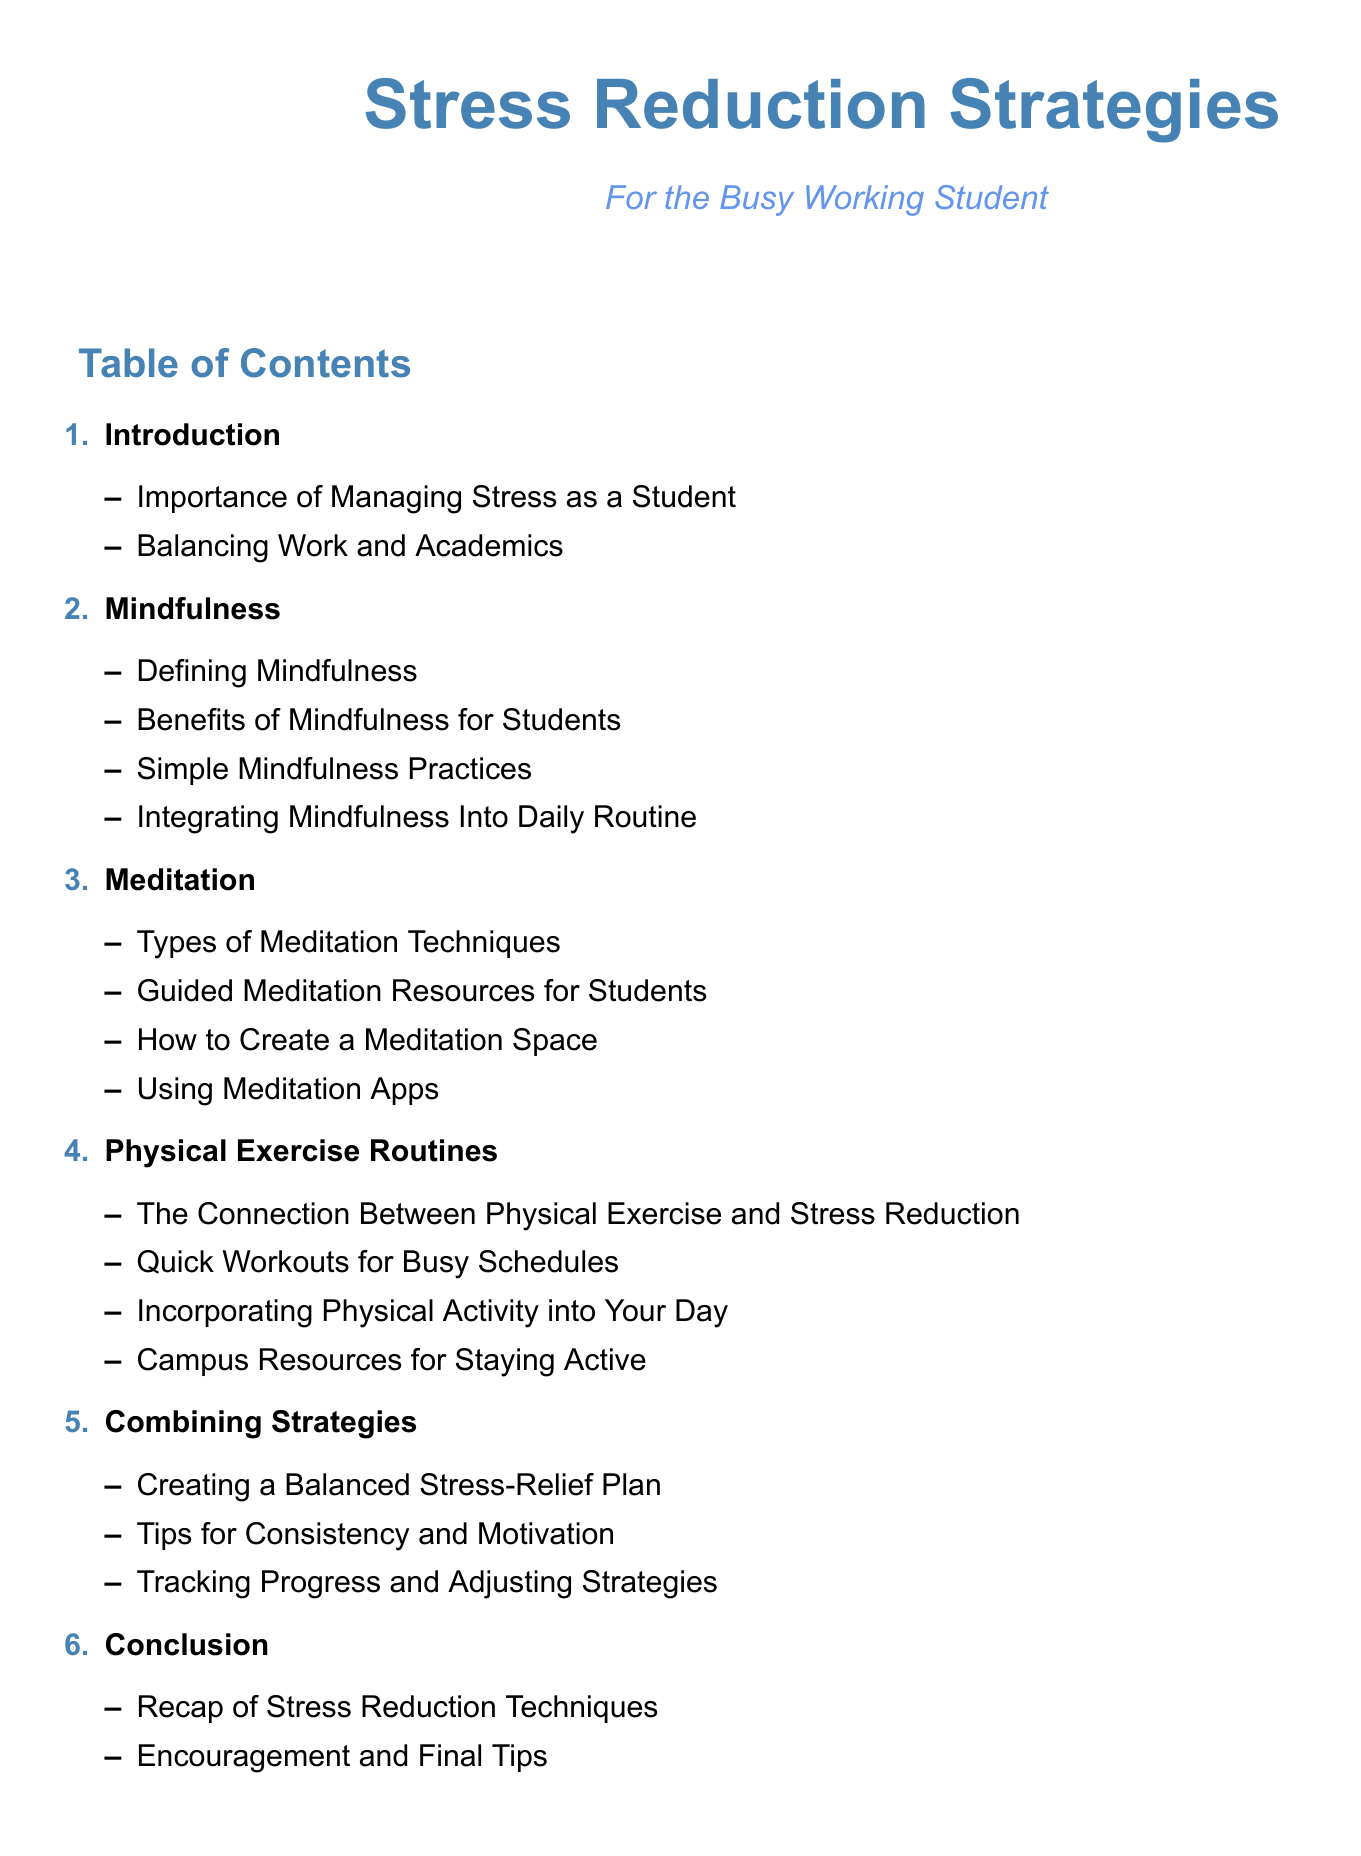What is the document about? The document provides strategies for stress reduction specifically oriented for busy working students.
Answer: Stress Reduction Strategies How many main sections are included in the table of contents? The sections listed under the table of contents are numbered 1 through 6, indicating there are six main sections.
Answer: 6 What is one benefit of mindfulness mentioned? The document discusses mindfulness and its benefits, which are specific to students balancing work and academics.
Answer: Benefits of Mindfulness for Students What is a simple mindfulness practice suggested? The table of contents lists "Simple Mindfulness Practices" as a subsection under mindfulness, indicating practices that can be easily incorporated.
Answer: Simple Mindfulness Practices Which type of meditation resources does the document provide? The document includes suggestions for guided meditation resources that are accessible for students.
Answer: Guided Meditation Resources for Students What should students create to enhance their meditation experience? The document suggests creating a designated space for meditation to enhance the practice.
Answer: Create a Meditation Space How can students incorporate physical activity according to the document? The section on physical exercise outlines ways to integrate physical activity into a busy student's daily routine.
Answer: Incorporating Physical Activity into Your Day What strategy is recommended for maintaining stress relief consistency? There are tips provided specifically aimed at ensuring students remain consistent and motivated in their stress relief practices.
Answer: Tips for Consistency and Motivation What does the conclusion recap? The conclusion summarizes the various stress reduction techniques discussed throughout the document.
Answer: Recap of Stress Reduction Techniques 